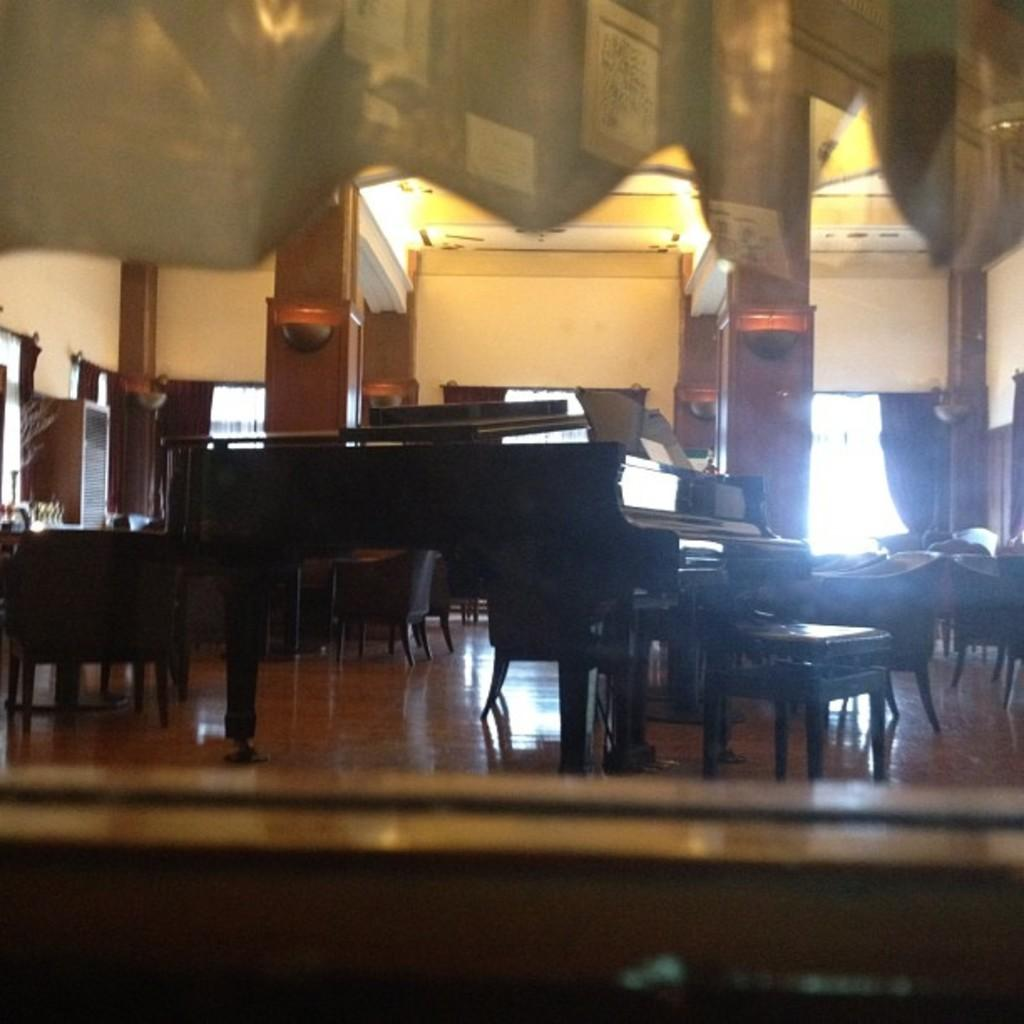What type of space is depicted in the image? There is a room in the image. What furniture is present in the room? There is a table and a chair in the room. What architectural features can be seen in the background of the image? In the background of the image, there is a pillar, a wall, a cupboard, and a window. What type of grain can be seen growing near the seashore in the image? There is no seashore or grain present in the image; it depicts a room with furniture and architectural features in the background. 